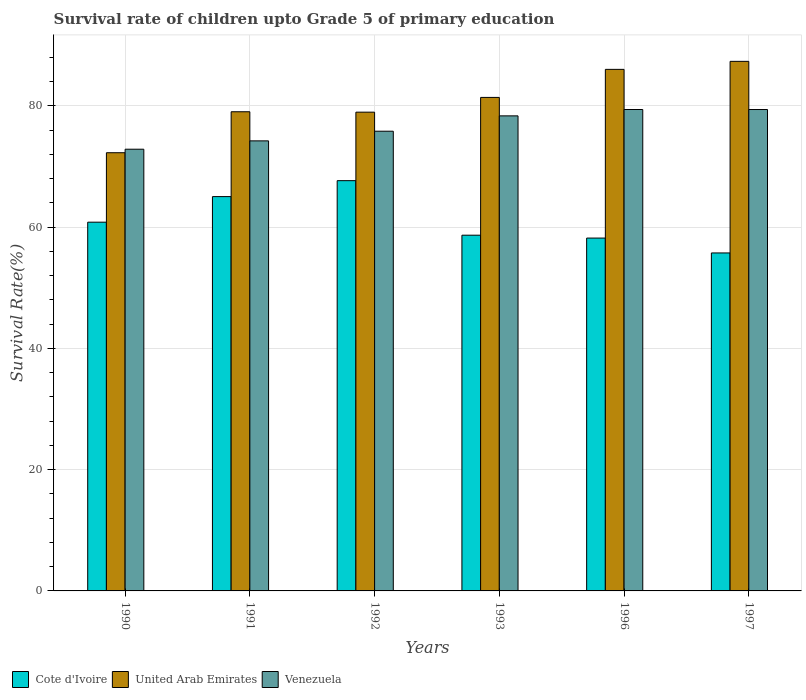How many different coloured bars are there?
Your response must be concise. 3. How many groups of bars are there?
Provide a succinct answer. 6. Are the number of bars per tick equal to the number of legend labels?
Offer a very short reply. Yes. How many bars are there on the 3rd tick from the right?
Give a very brief answer. 3. What is the survival rate of children in United Arab Emirates in 1993?
Offer a terse response. 81.39. Across all years, what is the maximum survival rate of children in Cote d'Ivoire?
Provide a succinct answer. 67.66. Across all years, what is the minimum survival rate of children in Venezuela?
Make the answer very short. 72.85. In which year was the survival rate of children in Venezuela minimum?
Your answer should be compact. 1990. What is the total survival rate of children in Cote d'Ivoire in the graph?
Provide a succinct answer. 366.12. What is the difference between the survival rate of children in Venezuela in 1991 and that in 1993?
Make the answer very short. -4.13. What is the difference between the survival rate of children in Venezuela in 1997 and the survival rate of children in United Arab Emirates in 1996?
Your response must be concise. -6.62. What is the average survival rate of children in Venezuela per year?
Keep it short and to the point. 76.67. In the year 1992, what is the difference between the survival rate of children in Venezuela and survival rate of children in United Arab Emirates?
Your response must be concise. -3.14. In how many years, is the survival rate of children in Venezuela greater than 8 %?
Provide a short and direct response. 6. What is the ratio of the survival rate of children in Venezuela in 1990 to that in 1993?
Your response must be concise. 0.93. Is the difference between the survival rate of children in Venezuela in 1990 and 1992 greater than the difference between the survival rate of children in United Arab Emirates in 1990 and 1992?
Your response must be concise. Yes. What is the difference between the highest and the second highest survival rate of children in Cote d'Ivoire?
Provide a short and direct response. 2.63. What is the difference between the highest and the lowest survival rate of children in Venezuela?
Provide a succinct answer. 6.55. Is the sum of the survival rate of children in United Arab Emirates in 1991 and 1996 greater than the maximum survival rate of children in Venezuela across all years?
Offer a terse response. Yes. What does the 2nd bar from the left in 1997 represents?
Keep it short and to the point. United Arab Emirates. What does the 1st bar from the right in 1996 represents?
Your response must be concise. Venezuela. How many bars are there?
Give a very brief answer. 18. Are all the bars in the graph horizontal?
Give a very brief answer. No. How many years are there in the graph?
Provide a succinct answer. 6. What is the difference between two consecutive major ticks on the Y-axis?
Ensure brevity in your answer.  20. Does the graph contain grids?
Offer a very short reply. Yes. How are the legend labels stacked?
Make the answer very short. Horizontal. What is the title of the graph?
Ensure brevity in your answer.  Survival rate of children upto Grade 5 of primary education. What is the label or title of the Y-axis?
Provide a succinct answer. Survival Rate(%). What is the Survival Rate(%) of Cote d'Ivoire in 1990?
Provide a succinct answer. 60.81. What is the Survival Rate(%) of United Arab Emirates in 1990?
Make the answer very short. 72.27. What is the Survival Rate(%) in Venezuela in 1990?
Provide a succinct answer. 72.85. What is the Survival Rate(%) in Cote d'Ivoire in 1991?
Offer a very short reply. 65.03. What is the Survival Rate(%) of United Arab Emirates in 1991?
Your answer should be compact. 79.03. What is the Survival Rate(%) in Venezuela in 1991?
Offer a terse response. 74.23. What is the Survival Rate(%) of Cote d'Ivoire in 1992?
Make the answer very short. 67.66. What is the Survival Rate(%) of United Arab Emirates in 1992?
Keep it short and to the point. 78.96. What is the Survival Rate(%) of Venezuela in 1992?
Offer a very short reply. 75.82. What is the Survival Rate(%) of Cote d'Ivoire in 1993?
Your response must be concise. 58.67. What is the Survival Rate(%) in United Arab Emirates in 1993?
Make the answer very short. 81.39. What is the Survival Rate(%) in Venezuela in 1993?
Provide a short and direct response. 78.35. What is the Survival Rate(%) of Cote d'Ivoire in 1996?
Give a very brief answer. 58.19. What is the Survival Rate(%) of United Arab Emirates in 1996?
Make the answer very short. 86.02. What is the Survival Rate(%) in Venezuela in 1996?
Your answer should be compact. 79.4. What is the Survival Rate(%) of Cote d'Ivoire in 1997?
Give a very brief answer. 55.74. What is the Survival Rate(%) in United Arab Emirates in 1997?
Offer a very short reply. 87.34. What is the Survival Rate(%) in Venezuela in 1997?
Give a very brief answer. 79.4. Across all years, what is the maximum Survival Rate(%) of Cote d'Ivoire?
Your answer should be compact. 67.66. Across all years, what is the maximum Survival Rate(%) of United Arab Emirates?
Your answer should be very brief. 87.34. Across all years, what is the maximum Survival Rate(%) in Venezuela?
Keep it short and to the point. 79.4. Across all years, what is the minimum Survival Rate(%) of Cote d'Ivoire?
Offer a terse response. 55.74. Across all years, what is the minimum Survival Rate(%) in United Arab Emirates?
Give a very brief answer. 72.27. Across all years, what is the minimum Survival Rate(%) of Venezuela?
Provide a succinct answer. 72.85. What is the total Survival Rate(%) in Cote d'Ivoire in the graph?
Offer a terse response. 366.12. What is the total Survival Rate(%) of United Arab Emirates in the graph?
Give a very brief answer. 485.01. What is the total Survival Rate(%) in Venezuela in the graph?
Provide a succinct answer. 460.04. What is the difference between the Survival Rate(%) in Cote d'Ivoire in 1990 and that in 1991?
Ensure brevity in your answer.  -4.22. What is the difference between the Survival Rate(%) of United Arab Emirates in 1990 and that in 1991?
Keep it short and to the point. -6.76. What is the difference between the Survival Rate(%) of Venezuela in 1990 and that in 1991?
Make the answer very short. -1.38. What is the difference between the Survival Rate(%) in Cote d'Ivoire in 1990 and that in 1992?
Ensure brevity in your answer.  -6.85. What is the difference between the Survival Rate(%) in United Arab Emirates in 1990 and that in 1992?
Make the answer very short. -6.69. What is the difference between the Survival Rate(%) in Venezuela in 1990 and that in 1992?
Give a very brief answer. -2.97. What is the difference between the Survival Rate(%) in Cote d'Ivoire in 1990 and that in 1993?
Ensure brevity in your answer.  2.15. What is the difference between the Survival Rate(%) of United Arab Emirates in 1990 and that in 1993?
Your answer should be compact. -9.12. What is the difference between the Survival Rate(%) of Venezuela in 1990 and that in 1993?
Offer a terse response. -5.5. What is the difference between the Survival Rate(%) of Cote d'Ivoire in 1990 and that in 1996?
Your response must be concise. 2.62. What is the difference between the Survival Rate(%) in United Arab Emirates in 1990 and that in 1996?
Offer a very short reply. -13.75. What is the difference between the Survival Rate(%) in Venezuela in 1990 and that in 1996?
Make the answer very short. -6.55. What is the difference between the Survival Rate(%) of Cote d'Ivoire in 1990 and that in 1997?
Offer a very short reply. 5.07. What is the difference between the Survival Rate(%) in United Arab Emirates in 1990 and that in 1997?
Offer a very short reply. -15.07. What is the difference between the Survival Rate(%) in Venezuela in 1990 and that in 1997?
Give a very brief answer. -6.55. What is the difference between the Survival Rate(%) in Cote d'Ivoire in 1991 and that in 1992?
Offer a terse response. -2.63. What is the difference between the Survival Rate(%) of United Arab Emirates in 1991 and that in 1992?
Keep it short and to the point. 0.07. What is the difference between the Survival Rate(%) of Venezuela in 1991 and that in 1992?
Make the answer very short. -1.59. What is the difference between the Survival Rate(%) in Cote d'Ivoire in 1991 and that in 1993?
Keep it short and to the point. 6.36. What is the difference between the Survival Rate(%) in United Arab Emirates in 1991 and that in 1993?
Your response must be concise. -2.36. What is the difference between the Survival Rate(%) in Venezuela in 1991 and that in 1993?
Offer a terse response. -4.13. What is the difference between the Survival Rate(%) in Cote d'Ivoire in 1991 and that in 1996?
Give a very brief answer. 6.84. What is the difference between the Survival Rate(%) of United Arab Emirates in 1991 and that in 1996?
Your answer should be very brief. -6.99. What is the difference between the Survival Rate(%) of Venezuela in 1991 and that in 1996?
Give a very brief answer. -5.17. What is the difference between the Survival Rate(%) in Cote d'Ivoire in 1991 and that in 1997?
Your response must be concise. 9.29. What is the difference between the Survival Rate(%) of United Arab Emirates in 1991 and that in 1997?
Make the answer very short. -8.31. What is the difference between the Survival Rate(%) in Venezuela in 1991 and that in 1997?
Provide a succinct answer. -5.17. What is the difference between the Survival Rate(%) of Cote d'Ivoire in 1992 and that in 1993?
Give a very brief answer. 8.99. What is the difference between the Survival Rate(%) of United Arab Emirates in 1992 and that in 1993?
Ensure brevity in your answer.  -2.43. What is the difference between the Survival Rate(%) in Venezuela in 1992 and that in 1993?
Ensure brevity in your answer.  -2.53. What is the difference between the Survival Rate(%) of Cote d'Ivoire in 1992 and that in 1996?
Give a very brief answer. 9.47. What is the difference between the Survival Rate(%) in United Arab Emirates in 1992 and that in 1996?
Make the answer very short. -7.06. What is the difference between the Survival Rate(%) of Venezuela in 1992 and that in 1996?
Your answer should be very brief. -3.58. What is the difference between the Survival Rate(%) in Cote d'Ivoire in 1992 and that in 1997?
Keep it short and to the point. 11.92. What is the difference between the Survival Rate(%) in United Arab Emirates in 1992 and that in 1997?
Offer a terse response. -8.38. What is the difference between the Survival Rate(%) of Venezuela in 1992 and that in 1997?
Make the answer very short. -3.58. What is the difference between the Survival Rate(%) in Cote d'Ivoire in 1993 and that in 1996?
Provide a succinct answer. 0.47. What is the difference between the Survival Rate(%) in United Arab Emirates in 1993 and that in 1996?
Keep it short and to the point. -4.62. What is the difference between the Survival Rate(%) in Venezuela in 1993 and that in 1996?
Your response must be concise. -1.05. What is the difference between the Survival Rate(%) in Cote d'Ivoire in 1993 and that in 1997?
Offer a very short reply. 2.93. What is the difference between the Survival Rate(%) of United Arab Emirates in 1993 and that in 1997?
Keep it short and to the point. -5.95. What is the difference between the Survival Rate(%) in Venezuela in 1993 and that in 1997?
Give a very brief answer. -1.04. What is the difference between the Survival Rate(%) in Cote d'Ivoire in 1996 and that in 1997?
Offer a terse response. 2.45. What is the difference between the Survival Rate(%) of United Arab Emirates in 1996 and that in 1997?
Provide a succinct answer. -1.32. What is the difference between the Survival Rate(%) in Venezuela in 1996 and that in 1997?
Your answer should be compact. 0. What is the difference between the Survival Rate(%) of Cote d'Ivoire in 1990 and the Survival Rate(%) of United Arab Emirates in 1991?
Your answer should be very brief. -18.21. What is the difference between the Survival Rate(%) in Cote d'Ivoire in 1990 and the Survival Rate(%) in Venezuela in 1991?
Your answer should be compact. -13.41. What is the difference between the Survival Rate(%) in United Arab Emirates in 1990 and the Survival Rate(%) in Venezuela in 1991?
Your response must be concise. -1.95. What is the difference between the Survival Rate(%) in Cote d'Ivoire in 1990 and the Survival Rate(%) in United Arab Emirates in 1992?
Ensure brevity in your answer.  -18.14. What is the difference between the Survival Rate(%) of Cote d'Ivoire in 1990 and the Survival Rate(%) of Venezuela in 1992?
Provide a succinct answer. -15.01. What is the difference between the Survival Rate(%) in United Arab Emirates in 1990 and the Survival Rate(%) in Venezuela in 1992?
Your answer should be compact. -3.55. What is the difference between the Survival Rate(%) of Cote d'Ivoire in 1990 and the Survival Rate(%) of United Arab Emirates in 1993?
Your answer should be very brief. -20.58. What is the difference between the Survival Rate(%) of Cote d'Ivoire in 1990 and the Survival Rate(%) of Venezuela in 1993?
Offer a very short reply. -17.54. What is the difference between the Survival Rate(%) of United Arab Emirates in 1990 and the Survival Rate(%) of Venezuela in 1993?
Keep it short and to the point. -6.08. What is the difference between the Survival Rate(%) of Cote d'Ivoire in 1990 and the Survival Rate(%) of United Arab Emirates in 1996?
Offer a very short reply. -25.2. What is the difference between the Survival Rate(%) in Cote d'Ivoire in 1990 and the Survival Rate(%) in Venezuela in 1996?
Offer a terse response. -18.58. What is the difference between the Survival Rate(%) in United Arab Emirates in 1990 and the Survival Rate(%) in Venezuela in 1996?
Offer a terse response. -7.13. What is the difference between the Survival Rate(%) in Cote d'Ivoire in 1990 and the Survival Rate(%) in United Arab Emirates in 1997?
Provide a short and direct response. -26.53. What is the difference between the Survival Rate(%) of Cote d'Ivoire in 1990 and the Survival Rate(%) of Venezuela in 1997?
Your response must be concise. -18.58. What is the difference between the Survival Rate(%) of United Arab Emirates in 1990 and the Survival Rate(%) of Venezuela in 1997?
Give a very brief answer. -7.12. What is the difference between the Survival Rate(%) of Cote d'Ivoire in 1991 and the Survival Rate(%) of United Arab Emirates in 1992?
Your answer should be compact. -13.93. What is the difference between the Survival Rate(%) of Cote d'Ivoire in 1991 and the Survival Rate(%) of Venezuela in 1992?
Your answer should be compact. -10.79. What is the difference between the Survival Rate(%) in United Arab Emirates in 1991 and the Survival Rate(%) in Venezuela in 1992?
Your answer should be very brief. 3.21. What is the difference between the Survival Rate(%) of Cote d'Ivoire in 1991 and the Survival Rate(%) of United Arab Emirates in 1993?
Your answer should be very brief. -16.36. What is the difference between the Survival Rate(%) in Cote d'Ivoire in 1991 and the Survival Rate(%) in Venezuela in 1993?
Give a very brief answer. -13.32. What is the difference between the Survival Rate(%) of United Arab Emirates in 1991 and the Survival Rate(%) of Venezuela in 1993?
Ensure brevity in your answer.  0.68. What is the difference between the Survival Rate(%) in Cote d'Ivoire in 1991 and the Survival Rate(%) in United Arab Emirates in 1996?
Give a very brief answer. -20.98. What is the difference between the Survival Rate(%) of Cote d'Ivoire in 1991 and the Survival Rate(%) of Venezuela in 1996?
Your answer should be very brief. -14.36. What is the difference between the Survival Rate(%) in United Arab Emirates in 1991 and the Survival Rate(%) in Venezuela in 1996?
Offer a very short reply. -0.37. What is the difference between the Survival Rate(%) of Cote d'Ivoire in 1991 and the Survival Rate(%) of United Arab Emirates in 1997?
Provide a short and direct response. -22.31. What is the difference between the Survival Rate(%) of Cote d'Ivoire in 1991 and the Survival Rate(%) of Venezuela in 1997?
Keep it short and to the point. -14.36. What is the difference between the Survival Rate(%) of United Arab Emirates in 1991 and the Survival Rate(%) of Venezuela in 1997?
Your answer should be compact. -0.37. What is the difference between the Survival Rate(%) in Cote d'Ivoire in 1992 and the Survival Rate(%) in United Arab Emirates in 1993?
Your answer should be very brief. -13.73. What is the difference between the Survival Rate(%) of Cote d'Ivoire in 1992 and the Survival Rate(%) of Venezuela in 1993?
Provide a short and direct response. -10.69. What is the difference between the Survival Rate(%) in United Arab Emirates in 1992 and the Survival Rate(%) in Venezuela in 1993?
Your response must be concise. 0.61. What is the difference between the Survival Rate(%) of Cote d'Ivoire in 1992 and the Survival Rate(%) of United Arab Emirates in 1996?
Offer a very short reply. -18.36. What is the difference between the Survival Rate(%) of Cote d'Ivoire in 1992 and the Survival Rate(%) of Venezuela in 1996?
Make the answer very short. -11.74. What is the difference between the Survival Rate(%) of United Arab Emirates in 1992 and the Survival Rate(%) of Venezuela in 1996?
Offer a very short reply. -0.44. What is the difference between the Survival Rate(%) in Cote d'Ivoire in 1992 and the Survival Rate(%) in United Arab Emirates in 1997?
Make the answer very short. -19.68. What is the difference between the Survival Rate(%) of Cote d'Ivoire in 1992 and the Survival Rate(%) of Venezuela in 1997?
Your answer should be compact. -11.73. What is the difference between the Survival Rate(%) of United Arab Emirates in 1992 and the Survival Rate(%) of Venezuela in 1997?
Make the answer very short. -0.44. What is the difference between the Survival Rate(%) of Cote d'Ivoire in 1993 and the Survival Rate(%) of United Arab Emirates in 1996?
Your response must be concise. -27.35. What is the difference between the Survival Rate(%) in Cote d'Ivoire in 1993 and the Survival Rate(%) in Venezuela in 1996?
Make the answer very short. -20.73. What is the difference between the Survival Rate(%) in United Arab Emirates in 1993 and the Survival Rate(%) in Venezuela in 1996?
Offer a terse response. 2. What is the difference between the Survival Rate(%) of Cote d'Ivoire in 1993 and the Survival Rate(%) of United Arab Emirates in 1997?
Provide a short and direct response. -28.67. What is the difference between the Survival Rate(%) of Cote d'Ivoire in 1993 and the Survival Rate(%) of Venezuela in 1997?
Keep it short and to the point. -20.73. What is the difference between the Survival Rate(%) in United Arab Emirates in 1993 and the Survival Rate(%) in Venezuela in 1997?
Give a very brief answer. 2. What is the difference between the Survival Rate(%) in Cote d'Ivoire in 1996 and the Survival Rate(%) in United Arab Emirates in 1997?
Keep it short and to the point. -29.15. What is the difference between the Survival Rate(%) in Cote d'Ivoire in 1996 and the Survival Rate(%) in Venezuela in 1997?
Offer a terse response. -21.2. What is the difference between the Survival Rate(%) in United Arab Emirates in 1996 and the Survival Rate(%) in Venezuela in 1997?
Provide a short and direct response. 6.62. What is the average Survival Rate(%) of Cote d'Ivoire per year?
Give a very brief answer. 61.02. What is the average Survival Rate(%) of United Arab Emirates per year?
Provide a succinct answer. 80.84. What is the average Survival Rate(%) in Venezuela per year?
Ensure brevity in your answer.  76.67. In the year 1990, what is the difference between the Survival Rate(%) in Cote d'Ivoire and Survival Rate(%) in United Arab Emirates?
Provide a succinct answer. -11.46. In the year 1990, what is the difference between the Survival Rate(%) of Cote d'Ivoire and Survival Rate(%) of Venezuela?
Your answer should be compact. -12.04. In the year 1990, what is the difference between the Survival Rate(%) in United Arab Emirates and Survival Rate(%) in Venezuela?
Your answer should be very brief. -0.58. In the year 1991, what is the difference between the Survival Rate(%) in Cote d'Ivoire and Survival Rate(%) in United Arab Emirates?
Give a very brief answer. -14. In the year 1991, what is the difference between the Survival Rate(%) of Cote d'Ivoire and Survival Rate(%) of Venezuela?
Offer a terse response. -9.19. In the year 1991, what is the difference between the Survival Rate(%) in United Arab Emirates and Survival Rate(%) in Venezuela?
Provide a succinct answer. 4.8. In the year 1992, what is the difference between the Survival Rate(%) in Cote d'Ivoire and Survival Rate(%) in United Arab Emirates?
Provide a succinct answer. -11.3. In the year 1992, what is the difference between the Survival Rate(%) of Cote d'Ivoire and Survival Rate(%) of Venezuela?
Give a very brief answer. -8.16. In the year 1992, what is the difference between the Survival Rate(%) of United Arab Emirates and Survival Rate(%) of Venezuela?
Your answer should be compact. 3.14. In the year 1993, what is the difference between the Survival Rate(%) of Cote d'Ivoire and Survival Rate(%) of United Arab Emirates?
Ensure brevity in your answer.  -22.72. In the year 1993, what is the difference between the Survival Rate(%) in Cote d'Ivoire and Survival Rate(%) in Venezuela?
Offer a terse response. -19.68. In the year 1993, what is the difference between the Survival Rate(%) of United Arab Emirates and Survival Rate(%) of Venezuela?
Keep it short and to the point. 3.04. In the year 1996, what is the difference between the Survival Rate(%) in Cote d'Ivoire and Survival Rate(%) in United Arab Emirates?
Ensure brevity in your answer.  -27.82. In the year 1996, what is the difference between the Survival Rate(%) in Cote d'Ivoire and Survival Rate(%) in Venezuela?
Offer a very short reply. -21.2. In the year 1996, what is the difference between the Survival Rate(%) of United Arab Emirates and Survival Rate(%) of Venezuela?
Your response must be concise. 6.62. In the year 1997, what is the difference between the Survival Rate(%) of Cote d'Ivoire and Survival Rate(%) of United Arab Emirates?
Keep it short and to the point. -31.6. In the year 1997, what is the difference between the Survival Rate(%) of Cote d'Ivoire and Survival Rate(%) of Venezuela?
Provide a succinct answer. -23.65. In the year 1997, what is the difference between the Survival Rate(%) of United Arab Emirates and Survival Rate(%) of Venezuela?
Make the answer very short. 7.95. What is the ratio of the Survival Rate(%) in Cote d'Ivoire in 1990 to that in 1991?
Your response must be concise. 0.94. What is the ratio of the Survival Rate(%) of United Arab Emirates in 1990 to that in 1991?
Offer a very short reply. 0.91. What is the ratio of the Survival Rate(%) of Venezuela in 1990 to that in 1991?
Make the answer very short. 0.98. What is the ratio of the Survival Rate(%) of Cote d'Ivoire in 1990 to that in 1992?
Provide a succinct answer. 0.9. What is the ratio of the Survival Rate(%) of United Arab Emirates in 1990 to that in 1992?
Your answer should be very brief. 0.92. What is the ratio of the Survival Rate(%) of Venezuela in 1990 to that in 1992?
Provide a succinct answer. 0.96. What is the ratio of the Survival Rate(%) of Cote d'Ivoire in 1990 to that in 1993?
Give a very brief answer. 1.04. What is the ratio of the Survival Rate(%) of United Arab Emirates in 1990 to that in 1993?
Offer a very short reply. 0.89. What is the ratio of the Survival Rate(%) in Venezuela in 1990 to that in 1993?
Provide a succinct answer. 0.93. What is the ratio of the Survival Rate(%) of Cote d'Ivoire in 1990 to that in 1996?
Offer a terse response. 1.04. What is the ratio of the Survival Rate(%) of United Arab Emirates in 1990 to that in 1996?
Offer a very short reply. 0.84. What is the ratio of the Survival Rate(%) of Venezuela in 1990 to that in 1996?
Ensure brevity in your answer.  0.92. What is the ratio of the Survival Rate(%) of Cote d'Ivoire in 1990 to that in 1997?
Provide a succinct answer. 1.09. What is the ratio of the Survival Rate(%) of United Arab Emirates in 1990 to that in 1997?
Provide a short and direct response. 0.83. What is the ratio of the Survival Rate(%) in Venezuela in 1990 to that in 1997?
Your answer should be compact. 0.92. What is the ratio of the Survival Rate(%) of Cote d'Ivoire in 1991 to that in 1992?
Your response must be concise. 0.96. What is the ratio of the Survival Rate(%) of United Arab Emirates in 1991 to that in 1992?
Offer a very short reply. 1. What is the ratio of the Survival Rate(%) in Cote d'Ivoire in 1991 to that in 1993?
Make the answer very short. 1.11. What is the ratio of the Survival Rate(%) in United Arab Emirates in 1991 to that in 1993?
Offer a very short reply. 0.97. What is the ratio of the Survival Rate(%) of Venezuela in 1991 to that in 1993?
Provide a short and direct response. 0.95. What is the ratio of the Survival Rate(%) of Cote d'Ivoire in 1991 to that in 1996?
Your answer should be very brief. 1.12. What is the ratio of the Survival Rate(%) of United Arab Emirates in 1991 to that in 1996?
Provide a short and direct response. 0.92. What is the ratio of the Survival Rate(%) of Venezuela in 1991 to that in 1996?
Offer a terse response. 0.93. What is the ratio of the Survival Rate(%) of Cote d'Ivoire in 1991 to that in 1997?
Your answer should be very brief. 1.17. What is the ratio of the Survival Rate(%) of United Arab Emirates in 1991 to that in 1997?
Provide a succinct answer. 0.9. What is the ratio of the Survival Rate(%) of Venezuela in 1991 to that in 1997?
Give a very brief answer. 0.93. What is the ratio of the Survival Rate(%) of Cote d'Ivoire in 1992 to that in 1993?
Keep it short and to the point. 1.15. What is the ratio of the Survival Rate(%) of United Arab Emirates in 1992 to that in 1993?
Keep it short and to the point. 0.97. What is the ratio of the Survival Rate(%) in Venezuela in 1992 to that in 1993?
Give a very brief answer. 0.97. What is the ratio of the Survival Rate(%) in Cote d'Ivoire in 1992 to that in 1996?
Offer a terse response. 1.16. What is the ratio of the Survival Rate(%) in United Arab Emirates in 1992 to that in 1996?
Keep it short and to the point. 0.92. What is the ratio of the Survival Rate(%) in Venezuela in 1992 to that in 1996?
Provide a succinct answer. 0.95. What is the ratio of the Survival Rate(%) in Cote d'Ivoire in 1992 to that in 1997?
Provide a short and direct response. 1.21. What is the ratio of the Survival Rate(%) of United Arab Emirates in 1992 to that in 1997?
Give a very brief answer. 0.9. What is the ratio of the Survival Rate(%) of Venezuela in 1992 to that in 1997?
Your answer should be compact. 0.95. What is the ratio of the Survival Rate(%) of Cote d'Ivoire in 1993 to that in 1996?
Provide a short and direct response. 1.01. What is the ratio of the Survival Rate(%) in United Arab Emirates in 1993 to that in 1996?
Ensure brevity in your answer.  0.95. What is the ratio of the Survival Rate(%) in Cote d'Ivoire in 1993 to that in 1997?
Give a very brief answer. 1.05. What is the ratio of the Survival Rate(%) of United Arab Emirates in 1993 to that in 1997?
Keep it short and to the point. 0.93. What is the ratio of the Survival Rate(%) of Cote d'Ivoire in 1996 to that in 1997?
Offer a terse response. 1.04. What is the ratio of the Survival Rate(%) of United Arab Emirates in 1996 to that in 1997?
Your response must be concise. 0.98. What is the difference between the highest and the second highest Survival Rate(%) of Cote d'Ivoire?
Keep it short and to the point. 2.63. What is the difference between the highest and the second highest Survival Rate(%) of United Arab Emirates?
Offer a terse response. 1.32. What is the difference between the highest and the second highest Survival Rate(%) of Venezuela?
Offer a terse response. 0. What is the difference between the highest and the lowest Survival Rate(%) of Cote d'Ivoire?
Provide a succinct answer. 11.92. What is the difference between the highest and the lowest Survival Rate(%) of United Arab Emirates?
Provide a short and direct response. 15.07. What is the difference between the highest and the lowest Survival Rate(%) of Venezuela?
Ensure brevity in your answer.  6.55. 